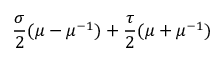<formula> <loc_0><loc_0><loc_500><loc_500>\frac { \sigma } { 2 } ( \mu - \mu ^ { - 1 } ) + \frac { \tau } { 2 } ( \mu + \mu ^ { - 1 } )</formula> 